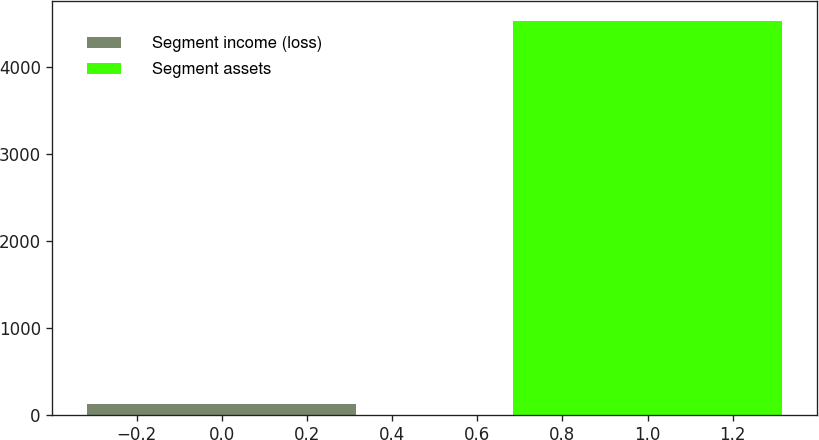<chart> <loc_0><loc_0><loc_500><loc_500><bar_chart><fcel>Segment income (loss)<fcel>Segment assets<nl><fcel>118<fcel>4534<nl></chart> 